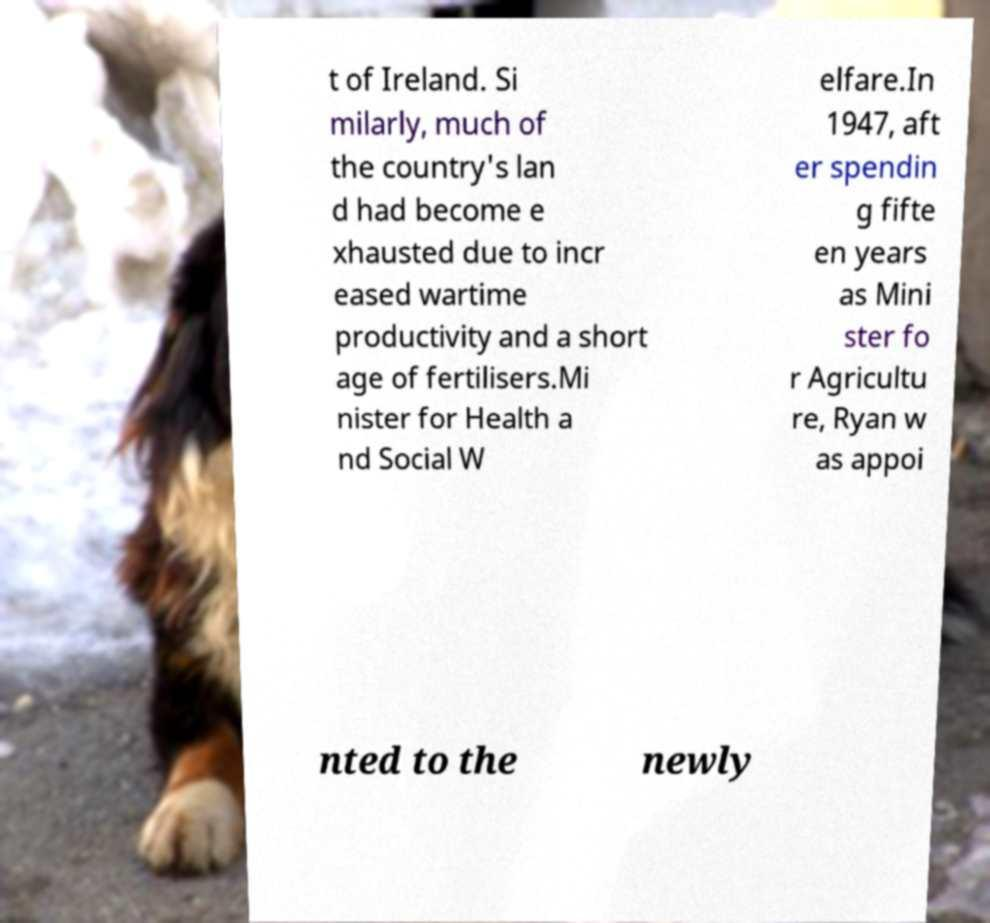There's text embedded in this image that I need extracted. Can you transcribe it verbatim? t of Ireland. Si milarly, much of the country's lan d had become e xhausted due to incr eased wartime productivity and a short age of fertilisers.Mi nister for Health a nd Social W elfare.In 1947, aft er spendin g fifte en years as Mini ster fo r Agricultu re, Ryan w as appoi nted to the newly 